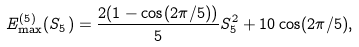Convert formula to latex. <formula><loc_0><loc_0><loc_500><loc_500>E _ { \max } ^ { ( 5 ) } ( S _ { 5 } ) = \frac { 2 ( 1 - \cos ( 2 \pi / 5 ) ) } { 5 } S _ { 5 } ^ { 2 } + 1 0 \cos ( 2 \pi / 5 ) ,</formula> 